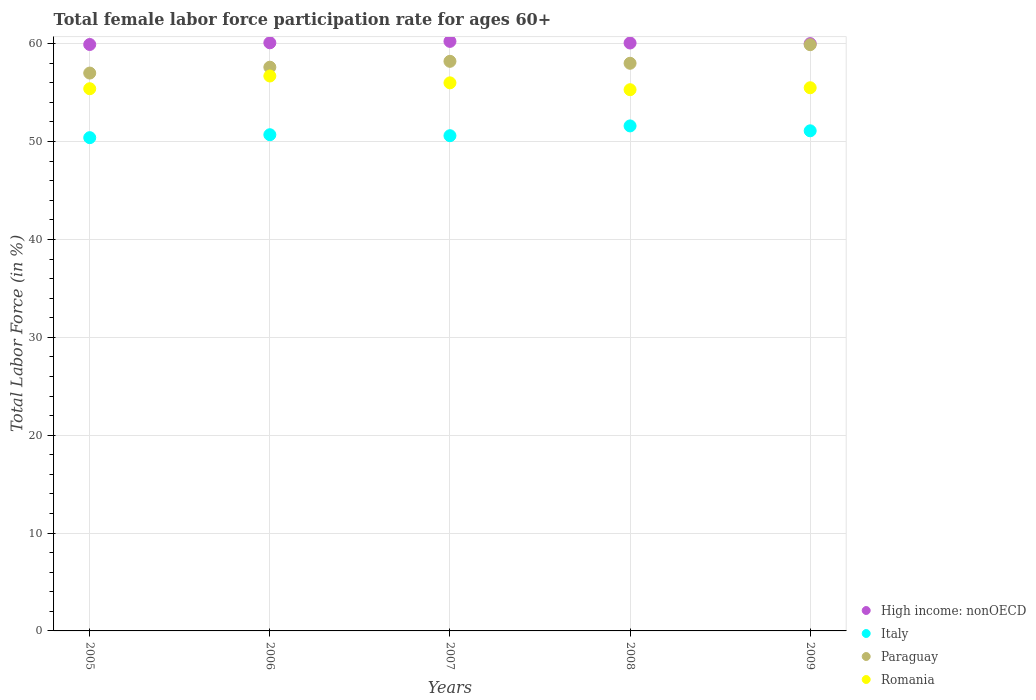How many different coloured dotlines are there?
Keep it short and to the point. 4. What is the female labor force participation rate in Paraguay in 2008?
Give a very brief answer. 58. Across all years, what is the maximum female labor force participation rate in High income: nonOECD?
Provide a succinct answer. 60.24. In which year was the female labor force participation rate in Paraguay maximum?
Keep it short and to the point. 2009. In which year was the female labor force participation rate in Paraguay minimum?
Offer a terse response. 2005. What is the total female labor force participation rate in Romania in the graph?
Your answer should be compact. 278.9. What is the difference between the female labor force participation rate in Romania in 2005 and that in 2009?
Your answer should be very brief. -0.1. What is the difference between the female labor force participation rate in Italy in 2006 and the female labor force participation rate in Paraguay in 2007?
Ensure brevity in your answer.  -7.5. What is the average female labor force participation rate in Italy per year?
Offer a terse response. 50.88. In the year 2006, what is the difference between the female labor force participation rate in Romania and female labor force participation rate in Italy?
Provide a succinct answer. 6. In how many years, is the female labor force participation rate in Romania greater than 28 %?
Your answer should be compact. 5. What is the ratio of the female labor force participation rate in High income: nonOECD in 2005 to that in 2009?
Your answer should be very brief. 1. Is the female labor force participation rate in High income: nonOECD in 2005 less than that in 2009?
Provide a short and direct response. Yes. Is the difference between the female labor force participation rate in Romania in 2005 and 2008 greater than the difference between the female labor force participation rate in Italy in 2005 and 2008?
Your answer should be compact. Yes. What is the difference between the highest and the second highest female labor force participation rate in High income: nonOECD?
Your answer should be very brief. 0.14. What is the difference between the highest and the lowest female labor force participation rate in High income: nonOECD?
Give a very brief answer. 0.32. In how many years, is the female labor force participation rate in Italy greater than the average female labor force participation rate in Italy taken over all years?
Give a very brief answer. 2. Is the sum of the female labor force participation rate in Romania in 2005 and 2007 greater than the maximum female labor force participation rate in High income: nonOECD across all years?
Offer a terse response. Yes. Is it the case that in every year, the sum of the female labor force participation rate in Romania and female labor force participation rate in High income: nonOECD  is greater than the sum of female labor force participation rate in Italy and female labor force participation rate in Paraguay?
Your answer should be compact. Yes. Is the female labor force participation rate in Paraguay strictly less than the female labor force participation rate in High income: nonOECD over the years?
Give a very brief answer. Yes. How many dotlines are there?
Offer a terse response. 4. How many years are there in the graph?
Ensure brevity in your answer.  5. Does the graph contain grids?
Give a very brief answer. Yes. Where does the legend appear in the graph?
Your response must be concise. Bottom right. How many legend labels are there?
Ensure brevity in your answer.  4. How are the legend labels stacked?
Provide a short and direct response. Vertical. What is the title of the graph?
Your answer should be very brief. Total female labor force participation rate for ages 60+. What is the label or title of the Y-axis?
Provide a succinct answer. Total Labor Force (in %). What is the Total Labor Force (in %) in High income: nonOECD in 2005?
Offer a very short reply. 59.92. What is the Total Labor Force (in %) of Italy in 2005?
Your answer should be very brief. 50.4. What is the Total Labor Force (in %) in Paraguay in 2005?
Offer a terse response. 57. What is the Total Labor Force (in %) in Romania in 2005?
Keep it short and to the point. 55.4. What is the Total Labor Force (in %) of High income: nonOECD in 2006?
Give a very brief answer. 60.09. What is the Total Labor Force (in %) of Italy in 2006?
Your answer should be compact. 50.7. What is the Total Labor Force (in %) in Paraguay in 2006?
Ensure brevity in your answer.  57.6. What is the Total Labor Force (in %) of Romania in 2006?
Ensure brevity in your answer.  56.7. What is the Total Labor Force (in %) of High income: nonOECD in 2007?
Your answer should be very brief. 60.24. What is the Total Labor Force (in %) in Italy in 2007?
Provide a succinct answer. 50.6. What is the Total Labor Force (in %) of Paraguay in 2007?
Ensure brevity in your answer.  58.2. What is the Total Labor Force (in %) in Romania in 2007?
Keep it short and to the point. 56. What is the Total Labor Force (in %) in High income: nonOECD in 2008?
Provide a short and direct response. 60.07. What is the Total Labor Force (in %) of Italy in 2008?
Your answer should be very brief. 51.6. What is the Total Labor Force (in %) in Paraguay in 2008?
Ensure brevity in your answer.  58. What is the Total Labor Force (in %) in Romania in 2008?
Provide a succinct answer. 55.3. What is the Total Labor Force (in %) in High income: nonOECD in 2009?
Give a very brief answer. 60.01. What is the Total Labor Force (in %) in Italy in 2009?
Make the answer very short. 51.1. What is the Total Labor Force (in %) in Paraguay in 2009?
Provide a short and direct response. 59.9. What is the Total Labor Force (in %) of Romania in 2009?
Your answer should be compact. 55.5. Across all years, what is the maximum Total Labor Force (in %) in High income: nonOECD?
Keep it short and to the point. 60.24. Across all years, what is the maximum Total Labor Force (in %) in Italy?
Your response must be concise. 51.6. Across all years, what is the maximum Total Labor Force (in %) of Paraguay?
Give a very brief answer. 59.9. Across all years, what is the maximum Total Labor Force (in %) of Romania?
Offer a very short reply. 56.7. Across all years, what is the minimum Total Labor Force (in %) in High income: nonOECD?
Provide a succinct answer. 59.92. Across all years, what is the minimum Total Labor Force (in %) in Italy?
Make the answer very short. 50.4. Across all years, what is the minimum Total Labor Force (in %) of Romania?
Provide a short and direct response. 55.3. What is the total Total Labor Force (in %) of High income: nonOECD in the graph?
Make the answer very short. 300.33. What is the total Total Labor Force (in %) in Italy in the graph?
Give a very brief answer. 254.4. What is the total Total Labor Force (in %) of Paraguay in the graph?
Ensure brevity in your answer.  290.7. What is the total Total Labor Force (in %) in Romania in the graph?
Keep it short and to the point. 278.9. What is the difference between the Total Labor Force (in %) of High income: nonOECD in 2005 and that in 2006?
Keep it short and to the point. -0.17. What is the difference between the Total Labor Force (in %) in Romania in 2005 and that in 2006?
Make the answer very short. -1.3. What is the difference between the Total Labor Force (in %) in High income: nonOECD in 2005 and that in 2007?
Provide a succinct answer. -0.32. What is the difference between the Total Labor Force (in %) in Italy in 2005 and that in 2007?
Keep it short and to the point. -0.2. What is the difference between the Total Labor Force (in %) in Paraguay in 2005 and that in 2007?
Your answer should be compact. -1.2. What is the difference between the Total Labor Force (in %) of High income: nonOECD in 2005 and that in 2008?
Your answer should be compact. -0.15. What is the difference between the Total Labor Force (in %) of Paraguay in 2005 and that in 2008?
Make the answer very short. -1. What is the difference between the Total Labor Force (in %) of High income: nonOECD in 2005 and that in 2009?
Your answer should be very brief. -0.09. What is the difference between the Total Labor Force (in %) of Italy in 2005 and that in 2009?
Give a very brief answer. -0.7. What is the difference between the Total Labor Force (in %) in Paraguay in 2005 and that in 2009?
Ensure brevity in your answer.  -2.9. What is the difference between the Total Labor Force (in %) of Romania in 2005 and that in 2009?
Make the answer very short. -0.1. What is the difference between the Total Labor Force (in %) of High income: nonOECD in 2006 and that in 2007?
Ensure brevity in your answer.  -0.14. What is the difference between the Total Labor Force (in %) of Italy in 2006 and that in 2007?
Give a very brief answer. 0.1. What is the difference between the Total Labor Force (in %) in Paraguay in 2006 and that in 2007?
Your answer should be compact. -0.6. What is the difference between the Total Labor Force (in %) in Romania in 2006 and that in 2007?
Ensure brevity in your answer.  0.7. What is the difference between the Total Labor Force (in %) in High income: nonOECD in 2006 and that in 2008?
Your answer should be compact. 0.02. What is the difference between the Total Labor Force (in %) in Romania in 2006 and that in 2008?
Make the answer very short. 1.4. What is the difference between the Total Labor Force (in %) in High income: nonOECD in 2006 and that in 2009?
Give a very brief answer. 0.09. What is the difference between the Total Labor Force (in %) of High income: nonOECD in 2007 and that in 2008?
Provide a short and direct response. 0.16. What is the difference between the Total Labor Force (in %) of Romania in 2007 and that in 2008?
Your answer should be compact. 0.7. What is the difference between the Total Labor Force (in %) of High income: nonOECD in 2007 and that in 2009?
Ensure brevity in your answer.  0.23. What is the difference between the Total Labor Force (in %) of Romania in 2007 and that in 2009?
Make the answer very short. 0.5. What is the difference between the Total Labor Force (in %) in High income: nonOECD in 2008 and that in 2009?
Give a very brief answer. 0.06. What is the difference between the Total Labor Force (in %) in Italy in 2008 and that in 2009?
Give a very brief answer. 0.5. What is the difference between the Total Labor Force (in %) of High income: nonOECD in 2005 and the Total Labor Force (in %) of Italy in 2006?
Offer a terse response. 9.22. What is the difference between the Total Labor Force (in %) in High income: nonOECD in 2005 and the Total Labor Force (in %) in Paraguay in 2006?
Keep it short and to the point. 2.32. What is the difference between the Total Labor Force (in %) of High income: nonOECD in 2005 and the Total Labor Force (in %) of Romania in 2006?
Provide a succinct answer. 3.22. What is the difference between the Total Labor Force (in %) of Italy in 2005 and the Total Labor Force (in %) of Romania in 2006?
Offer a very short reply. -6.3. What is the difference between the Total Labor Force (in %) of High income: nonOECD in 2005 and the Total Labor Force (in %) of Italy in 2007?
Give a very brief answer. 9.32. What is the difference between the Total Labor Force (in %) in High income: nonOECD in 2005 and the Total Labor Force (in %) in Paraguay in 2007?
Keep it short and to the point. 1.72. What is the difference between the Total Labor Force (in %) of High income: nonOECD in 2005 and the Total Labor Force (in %) of Romania in 2007?
Offer a very short reply. 3.92. What is the difference between the Total Labor Force (in %) of Italy in 2005 and the Total Labor Force (in %) of Romania in 2007?
Keep it short and to the point. -5.6. What is the difference between the Total Labor Force (in %) in High income: nonOECD in 2005 and the Total Labor Force (in %) in Italy in 2008?
Offer a very short reply. 8.32. What is the difference between the Total Labor Force (in %) in High income: nonOECD in 2005 and the Total Labor Force (in %) in Paraguay in 2008?
Offer a very short reply. 1.92. What is the difference between the Total Labor Force (in %) of High income: nonOECD in 2005 and the Total Labor Force (in %) of Romania in 2008?
Offer a very short reply. 4.62. What is the difference between the Total Labor Force (in %) in Italy in 2005 and the Total Labor Force (in %) in Romania in 2008?
Ensure brevity in your answer.  -4.9. What is the difference between the Total Labor Force (in %) in Paraguay in 2005 and the Total Labor Force (in %) in Romania in 2008?
Provide a short and direct response. 1.7. What is the difference between the Total Labor Force (in %) in High income: nonOECD in 2005 and the Total Labor Force (in %) in Italy in 2009?
Your answer should be compact. 8.82. What is the difference between the Total Labor Force (in %) of High income: nonOECD in 2005 and the Total Labor Force (in %) of Paraguay in 2009?
Your answer should be very brief. 0.02. What is the difference between the Total Labor Force (in %) of High income: nonOECD in 2005 and the Total Labor Force (in %) of Romania in 2009?
Offer a terse response. 4.42. What is the difference between the Total Labor Force (in %) of Italy in 2005 and the Total Labor Force (in %) of Romania in 2009?
Your answer should be compact. -5.1. What is the difference between the Total Labor Force (in %) in High income: nonOECD in 2006 and the Total Labor Force (in %) in Italy in 2007?
Keep it short and to the point. 9.49. What is the difference between the Total Labor Force (in %) in High income: nonOECD in 2006 and the Total Labor Force (in %) in Paraguay in 2007?
Give a very brief answer. 1.89. What is the difference between the Total Labor Force (in %) of High income: nonOECD in 2006 and the Total Labor Force (in %) of Romania in 2007?
Keep it short and to the point. 4.09. What is the difference between the Total Labor Force (in %) of Italy in 2006 and the Total Labor Force (in %) of Romania in 2007?
Ensure brevity in your answer.  -5.3. What is the difference between the Total Labor Force (in %) of High income: nonOECD in 2006 and the Total Labor Force (in %) of Italy in 2008?
Offer a terse response. 8.49. What is the difference between the Total Labor Force (in %) in High income: nonOECD in 2006 and the Total Labor Force (in %) in Paraguay in 2008?
Make the answer very short. 2.09. What is the difference between the Total Labor Force (in %) of High income: nonOECD in 2006 and the Total Labor Force (in %) of Romania in 2008?
Provide a succinct answer. 4.79. What is the difference between the Total Labor Force (in %) in Italy in 2006 and the Total Labor Force (in %) in Romania in 2008?
Your response must be concise. -4.6. What is the difference between the Total Labor Force (in %) of High income: nonOECD in 2006 and the Total Labor Force (in %) of Italy in 2009?
Your response must be concise. 8.99. What is the difference between the Total Labor Force (in %) in High income: nonOECD in 2006 and the Total Labor Force (in %) in Paraguay in 2009?
Offer a terse response. 0.19. What is the difference between the Total Labor Force (in %) of High income: nonOECD in 2006 and the Total Labor Force (in %) of Romania in 2009?
Give a very brief answer. 4.59. What is the difference between the Total Labor Force (in %) in Italy in 2006 and the Total Labor Force (in %) in Paraguay in 2009?
Ensure brevity in your answer.  -9.2. What is the difference between the Total Labor Force (in %) in High income: nonOECD in 2007 and the Total Labor Force (in %) in Italy in 2008?
Your answer should be compact. 8.64. What is the difference between the Total Labor Force (in %) of High income: nonOECD in 2007 and the Total Labor Force (in %) of Paraguay in 2008?
Keep it short and to the point. 2.24. What is the difference between the Total Labor Force (in %) in High income: nonOECD in 2007 and the Total Labor Force (in %) in Romania in 2008?
Keep it short and to the point. 4.94. What is the difference between the Total Labor Force (in %) in Italy in 2007 and the Total Labor Force (in %) in Paraguay in 2008?
Your answer should be compact. -7.4. What is the difference between the Total Labor Force (in %) of Italy in 2007 and the Total Labor Force (in %) of Romania in 2008?
Your answer should be very brief. -4.7. What is the difference between the Total Labor Force (in %) of Paraguay in 2007 and the Total Labor Force (in %) of Romania in 2008?
Your response must be concise. 2.9. What is the difference between the Total Labor Force (in %) of High income: nonOECD in 2007 and the Total Labor Force (in %) of Italy in 2009?
Ensure brevity in your answer.  9.14. What is the difference between the Total Labor Force (in %) of High income: nonOECD in 2007 and the Total Labor Force (in %) of Paraguay in 2009?
Give a very brief answer. 0.34. What is the difference between the Total Labor Force (in %) in High income: nonOECD in 2007 and the Total Labor Force (in %) in Romania in 2009?
Keep it short and to the point. 4.74. What is the difference between the Total Labor Force (in %) in Italy in 2007 and the Total Labor Force (in %) in Paraguay in 2009?
Offer a terse response. -9.3. What is the difference between the Total Labor Force (in %) of High income: nonOECD in 2008 and the Total Labor Force (in %) of Italy in 2009?
Keep it short and to the point. 8.97. What is the difference between the Total Labor Force (in %) of High income: nonOECD in 2008 and the Total Labor Force (in %) of Paraguay in 2009?
Make the answer very short. 0.17. What is the difference between the Total Labor Force (in %) in High income: nonOECD in 2008 and the Total Labor Force (in %) in Romania in 2009?
Give a very brief answer. 4.57. What is the difference between the Total Labor Force (in %) of Italy in 2008 and the Total Labor Force (in %) of Paraguay in 2009?
Make the answer very short. -8.3. What is the difference between the Total Labor Force (in %) of Italy in 2008 and the Total Labor Force (in %) of Romania in 2009?
Your answer should be very brief. -3.9. What is the difference between the Total Labor Force (in %) in Paraguay in 2008 and the Total Labor Force (in %) in Romania in 2009?
Offer a very short reply. 2.5. What is the average Total Labor Force (in %) in High income: nonOECD per year?
Provide a short and direct response. 60.07. What is the average Total Labor Force (in %) of Italy per year?
Offer a terse response. 50.88. What is the average Total Labor Force (in %) of Paraguay per year?
Keep it short and to the point. 58.14. What is the average Total Labor Force (in %) in Romania per year?
Your answer should be compact. 55.78. In the year 2005, what is the difference between the Total Labor Force (in %) of High income: nonOECD and Total Labor Force (in %) of Italy?
Provide a succinct answer. 9.52. In the year 2005, what is the difference between the Total Labor Force (in %) of High income: nonOECD and Total Labor Force (in %) of Paraguay?
Your answer should be very brief. 2.92. In the year 2005, what is the difference between the Total Labor Force (in %) of High income: nonOECD and Total Labor Force (in %) of Romania?
Offer a terse response. 4.52. In the year 2005, what is the difference between the Total Labor Force (in %) in Paraguay and Total Labor Force (in %) in Romania?
Offer a very short reply. 1.6. In the year 2006, what is the difference between the Total Labor Force (in %) in High income: nonOECD and Total Labor Force (in %) in Italy?
Offer a terse response. 9.39. In the year 2006, what is the difference between the Total Labor Force (in %) of High income: nonOECD and Total Labor Force (in %) of Paraguay?
Keep it short and to the point. 2.49. In the year 2006, what is the difference between the Total Labor Force (in %) of High income: nonOECD and Total Labor Force (in %) of Romania?
Make the answer very short. 3.39. In the year 2006, what is the difference between the Total Labor Force (in %) of Italy and Total Labor Force (in %) of Romania?
Ensure brevity in your answer.  -6. In the year 2006, what is the difference between the Total Labor Force (in %) in Paraguay and Total Labor Force (in %) in Romania?
Provide a succinct answer. 0.9. In the year 2007, what is the difference between the Total Labor Force (in %) in High income: nonOECD and Total Labor Force (in %) in Italy?
Make the answer very short. 9.64. In the year 2007, what is the difference between the Total Labor Force (in %) of High income: nonOECD and Total Labor Force (in %) of Paraguay?
Make the answer very short. 2.04. In the year 2007, what is the difference between the Total Labor Force (in %) of High income: nonOECD and Total Labor Force (in %) of Romania?
Give a very brief answer. 4.24. In the year 2007, what is the difference between the Total Labor Force (in %) of Italy and Total Labor Force (in %) of Paraguay?
Make the answer very short. -7.6. In the year 2007, what is the difference between the Total Labor Force (in %) of Italy and Total Labor Force (in %) of Romania?
Your answer should be compact. -5.4. In the year 2007, what is the difference between the Total Labor Force (in %) of Paraguay and Total Labor Force (in %) of Romania?
Make the answer very short. 2.2. In the year 2008, what is the difference between the Total Labor Force (in %) in High income: nonOECD and Total Labor Force (in %) in Italy?
Offer a very short reply. 8.47. In the year 2008, what is the difference between the Total Labor Force (in %) in High income: nonOECD and Total Labor Force (in %) in Paraguay?
Ensure brevity in your answer.  2.07. In the year 2008, what is the difference between the Total Labor Force (in %) in High income: nonOECD and Total Labor Force (in %) in Romania?
Offer a terse response. 4.77. In the year 2008, what is the difference between the Total Labor Force (in %) of Italy and Total Labor Force (in %) of Paraguay?
Offer a very short reply. -6.4. In the year 2009, what is the difference between the Total Labor Force (in %) in High income: nonOECD and Total Labor Force (in %) in Italy?
Offer a terse response. 8.91. In the year 2009, what is the difference between the Total Labor Force (in %) of High income: nonOECD and Total Labor Force (in %) of Paraguay?
Provide a short and direct response. 0.11. In the year 2009, what is the difference between the Total Labor Force (in %) of High income: nonOECD and Total Labor Force (in %) of Romania?
Give a very brief answer. 4.51. What is the ratio of the Total Labor Force (in %) in High income: nonOECD in 2005 to that in 2006?
Your response must be concise. 1. What is the ratio of the Total Labor Force (in %) of Italy in 2005 to that in 2006?
Your answer should be compact. 0.99. What is the ratio of the Total Labor Force (in %) of Romania in 2005 to that in 2006?
Keep it short and to the point. 0.98. What is the ratio of the Total Labor Force (in %) in Paraguay in 2005 to that in 2007?
Your answer should be very brief. 0.98. What is the ratio of the Total Labor Force (in %) of Romania in 2005 to that in 2007?
Offer a terse response. 0.99. What is the ratio of the Total Labor Force (in %) in Italy in 2005 to that in 2008?
Your answer should be very brief. 0.98. What is the ratio of the Total Labor Force (in %) in Paraguay in 2005 to that in 2008?
Provide a succinct answer. 0.98. What is the ratio of the Total Labor Force (in %) of High income: nonOECD in 2005 to that in 2009?
Your answer should be compact. 1. What is the ratio of the Total Labor Force (in %) in Italy in 2005 to that in 2009?
Make the answer very short. 0.99. What is the ratio of the Total Labor Force (in %) of Paraguay in 2005 to that in 2009?
Offer a terse response. 0.95. What is the ratio of the Total Labor Force (in %) in Romania in 2006 to that in 2007?
Offer a terse response. 1.01. What is the ratio of the Total Labor Force (in %) in Italy in 2006 to that in 2008?
Your answer should be very brief. 0.98. What is the ratio of the Total Labor Force (in %) in Paraguay in 2006 to that in 2008?
Offer a very short reply. 0.99. What is the ratio of the Total Labor Force (in %) in Romania in 2006 to that in 2008?
Offer a terse response. 1.03. What is the ratio of the Total Labor Force (in %) in Paraguay in 2006 to that in 2009?
Offer a terse response. 0.96. What is the ratio of the Total Labor Force (in %) of Romania in 2006 to that in 2009?
Offer a very short reply. 1.02. What is the ratio of the Total Labor Force (in %) of High income: nonOECD in 2007 to that in 2008?
Make the answer very short. 1. What is the ratio of the Total Labor Force (in %) in Italy in 2007 to that in 2008?
Offer a terse response. 0.98. What is the ratio of the Total Labor Force (in %) in Paraguay in 2007 to that in 2008?
Your answer should be compact. 1. What is the ratio of the Total Labor Force (in %) of Romania in 2007 to that in 2008?
Your response must be concise. 1.01. What is the ratio of the Total Labor Force (in %) in Italy in 2007 to that in 2009?
Provide a succinct answer. 0.99. What is the ratio of the Total Labor Force (in %) in Paraguay in 2007 to that in 2009?
Make the answer very short. 0.97. What is the ratio of the Total Labor Force (in %) of Italy in 2008 to that in 2009?
Give a very brief answer. 1.01. What is the ratio of the Total Labor Force (in %) of Paraguay in 2008 to that in 2009?
Ensure brevity in your answer.  0.97. What is the difference between the highest and the second highest Total Labor Force (in %) in High income: nonOECD?
Your answer should be compact. 0.14. What is the difference between the highest and the second highest Total Labor Force (in %) in Romania?
Provide a succinct answer. 0.7. What is the difference between the highest and the lowest Total Labor Force (in %) in High income: nonOECD?
Make the answer very short. 0.32. What is the difference between the highest and the lowest Total Labor Force (in %) in Romania?
Offer a terse response. 1.4. 